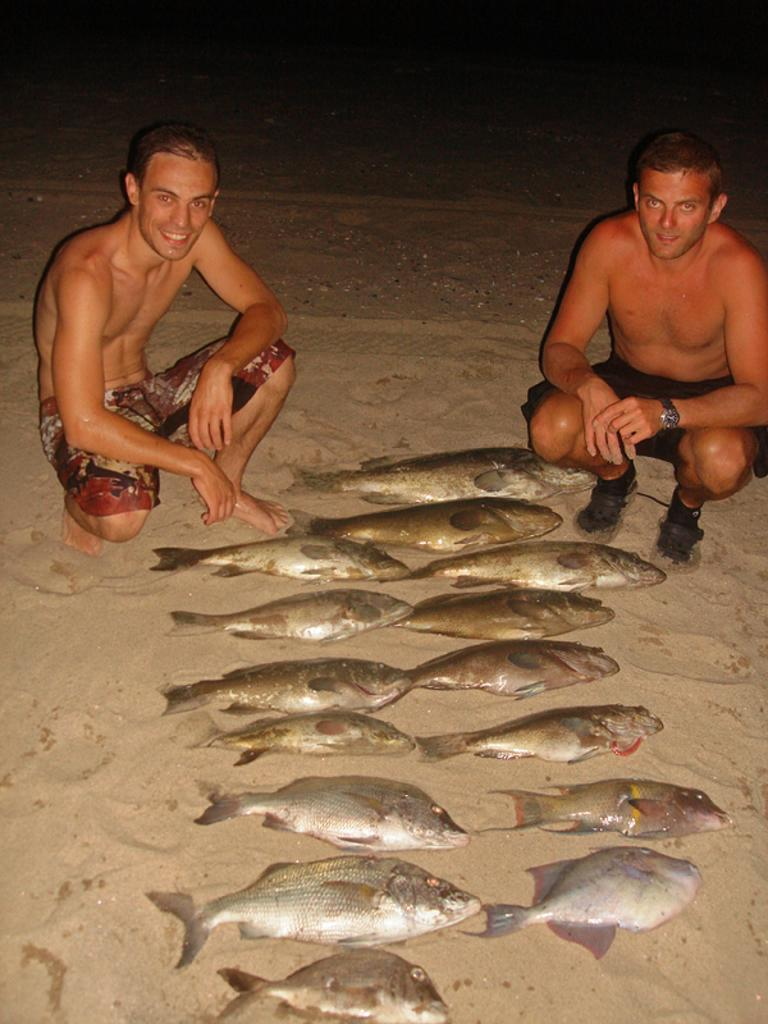How many people are in the image? There are two persons in the image. What is the facial expression of the persons? The persons are smiling. What can be seen on the sand in front of the two persons? There is a fish on the surface of the sand. What type of list is being held by the farmer in the image? There is no farmer or list present in the image. What is the yoke used for in the image? There is no yoke present in the image. 